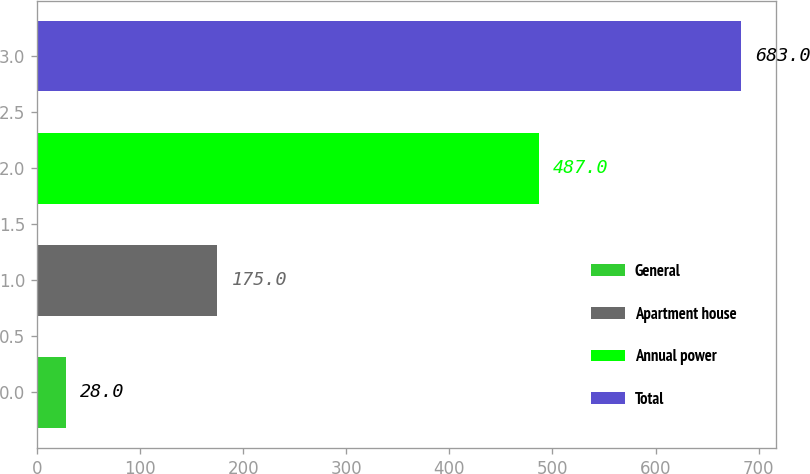<chart> <loc_0><loc_0><loc_500><loc_500><bar_chart><fcel>General<fcel>Apartment house<fcel>Annual power<fcel>Total<nl><fcel>28<fcel>175<fcel>487<fcel>683<nl></chart> 